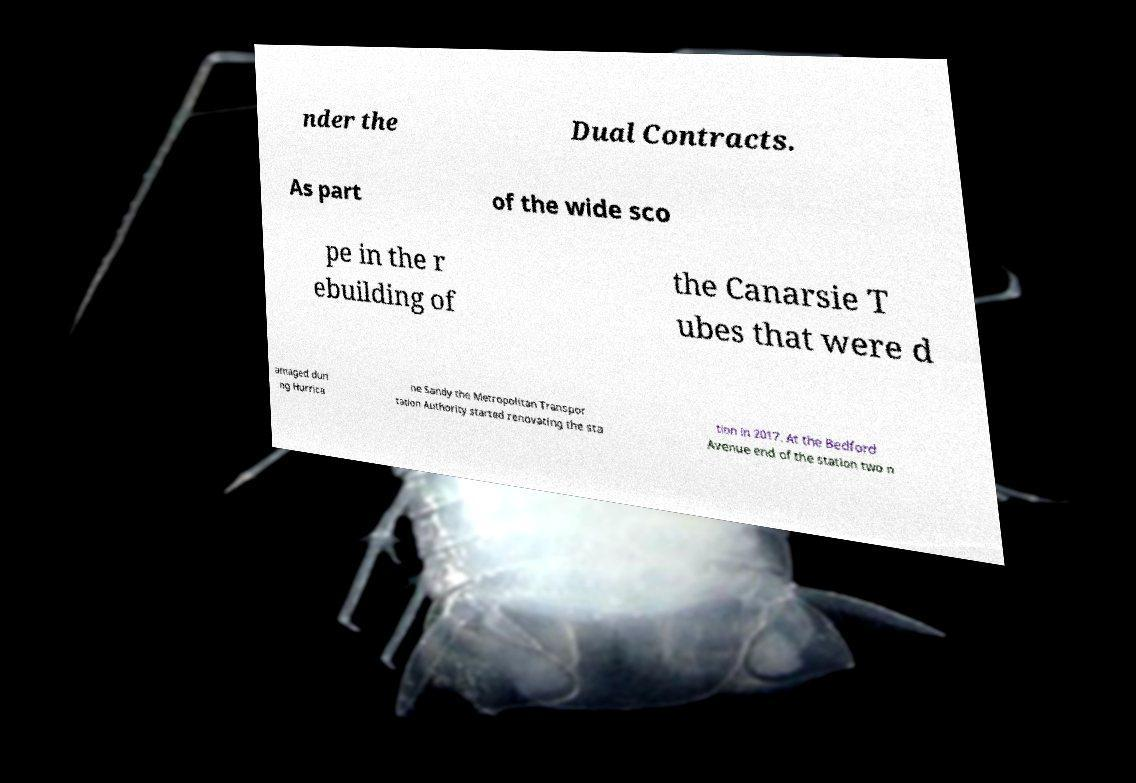What messages or text are displayed in this image? I need them in a readable, typed format. nder the Dual Contracts. As part of the wide sco pe in the r ebuilding of the Canarsie T ubes that were d amaged duri ng Hurrica ne Sandy the Metropolitan Transpor tation Authority started renovating the sta tion in 2017. At the Bedford Avenue end of the station two n 